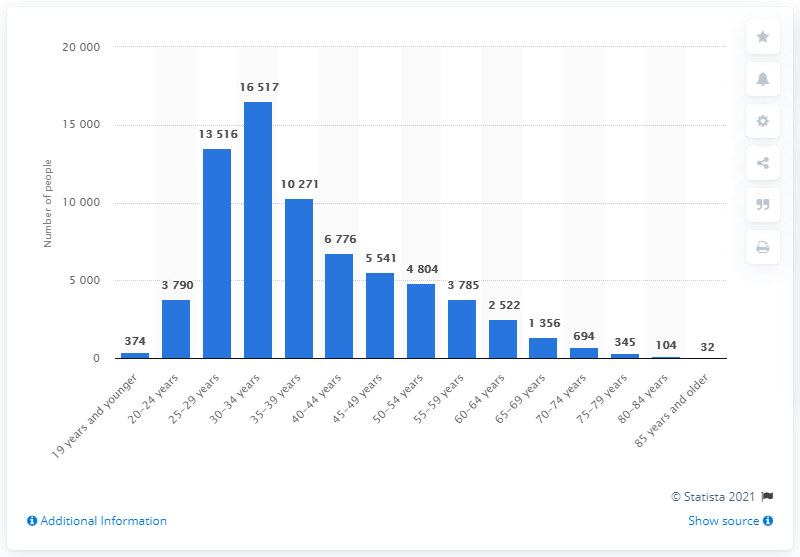Identify some key points in this picture. In 2020, a total of 16,517 newlyweds were married in Sweden. 